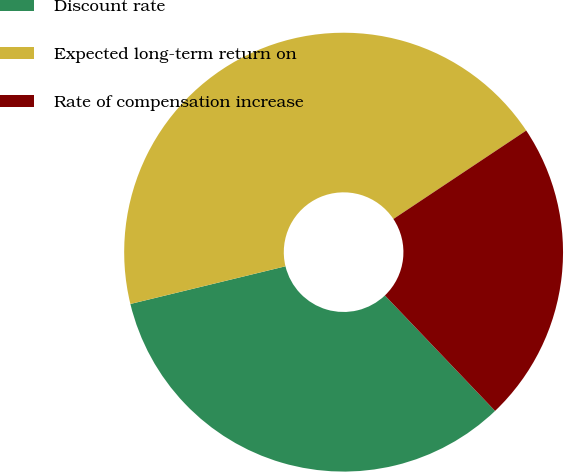Convert chart. <chart><loc_0><loc_0><loc_500><loc_500><pie_chart><fcel>Discount rate<fcel>Expected long-term return on<fcel>Rate of compensation increase<nl><fcel>33.33%<fcel>44.44%<fcel>22.22%<nl></chart> 